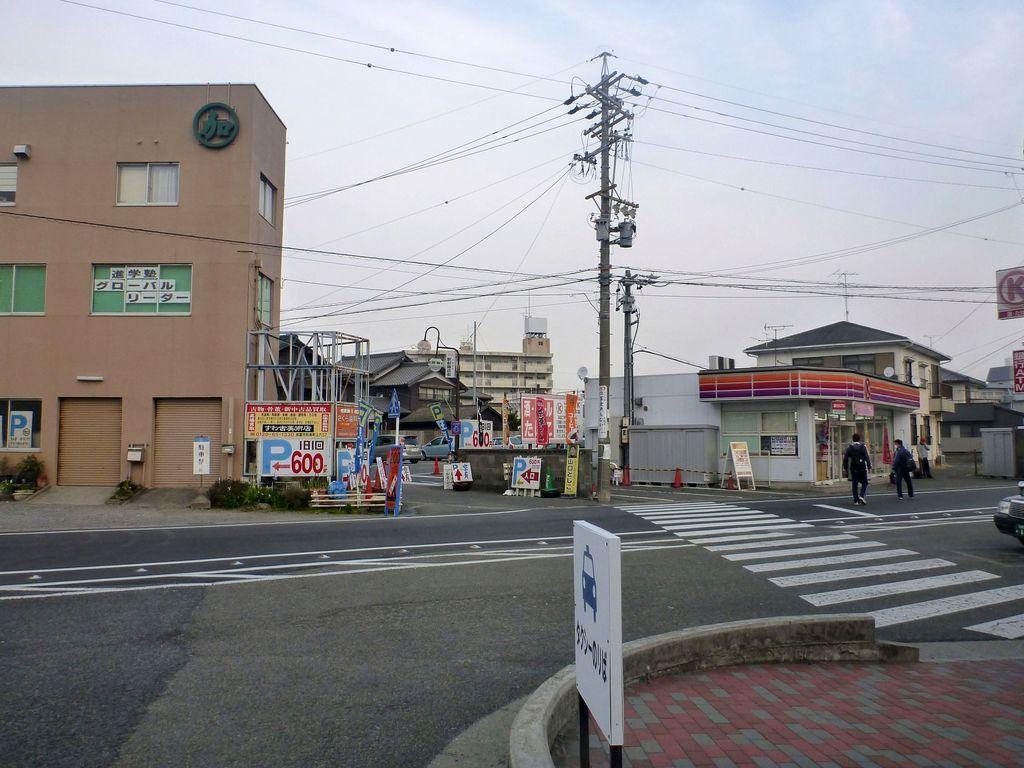Please provide a concise description of this image. In the foreground of this image, there is a board on the pavement and we can also see a road. In the background, there are boards, buildings, poles, cables and sky. We can also see a bumper of a vehicle on the right and also two people walking on the road. 